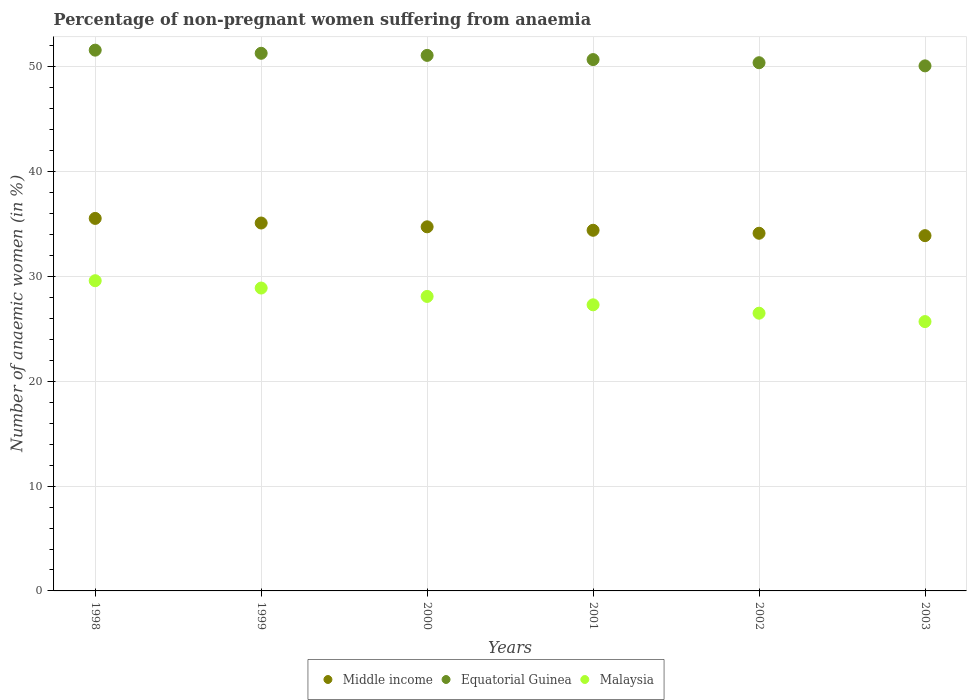How many different coloured dotlines are there?
Offer a terse response. 3. Is the number of dotlines equal to the number of legend labels?
Ensure brevity in your answer.  Yes. What is the percentage of non-pregnant women suffering from anaemia in Malaysia in 1999?
Your response must be concise. 28.9. Across all years, what is the maximum percentage of non-pregnant women suffering from anaemia in Malaysia?
Provide a succinct answer. 29.6. Across all years, what is the minimum percentage of non-pregnant women suffering from anaemia in Equatorial Guinea?
Keep it short and to the point. 50.1. In which year was the percentage of non-pregnant women suffering from anaemia in Malaysia maximum?
Your response must be concise. 1998. In which year was the percentage of non-pregnant women suffering from anaemia in Middle income minimum?
Make the answer very short. 2003. What is the total percentage of non-pregnant women suffering from anaemia in Equatorial Guinea in the graph?
Your answer should be very brief. 305.2. What is the difference between the percentage of non-pregnant women suffering from anaemia in Equatorial Guinea in 2000 and that in 2001?
Keep it short and to the point. 0.4. What is the difference between the percentage of non-pregnant women suffering from anaemia in Middle income in 2002 and the percentage of non-pregnant women suffering from anaemia in Malaysia in 2000?
Give a very brief answer. 6.03. What is the average percentage of non-pregnant women suffering from anaemia in Equatorial Guinea per year?
Keep it short and to the point. 50.87. In the year 2002, what is the difference between the percentage of non-pregnant women suffering from anaemia in Malaysia and percentage of non-pregnant women suffering from anaemia in Middle income?
Make the answer very short. -7.63. What is the ratio of the percentage of non-pregnant women suffering from anaemia in Middle income in 2000 to that in 2001?
Your answer should be compact. 1.01. What is the difference between the highest and the second highest percentage of non-pregnant women suffering from anaemia in Malaysia?
Give a very brief answer. 0.7. What is the difference between the highest and the lowest percentage of non-pregnant women suffering from anaemia in Middle income?
Give a very brief answer. 1.64. In how many years, is the percentage of non-pregnant women suffering from anaemia in Equatorial Guinea greater than the average percentage of non-pregnant women suffering from anaemia in Equatorial Guinea taken over all years?
Provide a succinct answer. 3. Is it the case that in every year, the sum of the percentage of non-pregnant women suffering from anaemia in Equatorial Guinea and percentage of non-pregnant women suffering from anaemia in Middle income  is greater than the percentage of non-pregnant women suffering from anaemia in Malaysia?
Provide a succinct answer. Yes. Does the percentage of non-pregnant women suffering from anaemia in Middle income monotonically increase over the years?
Provide a succinct answer. No. Is the percentage of non-pregnant women suffering from anaemia in Middle income strictly greater than the percentage of non-pregnant women suffering from anaemia in Malaysia over the years?
Your answer should be very brief. Yes. Is the percentage of non-pregnant women suffering from anaemia in Middle income strictly less than the percentage of non-pregnant women suffering from anaemia in Equatorial Guinea over the years?
Make the answer very short. Yes. How many years are there in the graph?
Offer a very short reply. 6. What is the difference between two consecutive major ticks on the Y-axis?
Provide a succinct answer. 10. Are the values on the major ticks of Y-axis written in scientific E-notation?
Make the answer very short. No. Does the graph contain grids?
Your answer should be compact. Yes. Where does the legend appear in the graph?
Provide a succinct answer. Bottom center. How are the legend labels stacked?
Offer a very short reply. Horizontal. What is the title of the graph?
Give a very brief answer. Percentage of non-pregnant women suffering from anaemia. Does "Latvia" appear as one of the legend labels in the graph?
Your response must be concise. No. What is the label or title of the Y-axis?
Make the answer very short. Number of anaemic women (in %). What is the Number of anaemic women (in %) of Middle income in 1998?
Your response must be concise. 35.54. What is the Number of anaemic women (in %) in Equatorial Guinea in 1998?
Make the answer very short. 51.6. What is the Number of anaemic women (in %) of Malaysia in 1998?
Ensure brevity in your answer.  29.6. What is the Number of anaemic women (in %) in Middle income in 1999?
Make the answer very short. 35.1. What is the Number of anaemic women (in %) of Equatorial Guinea in 1999?
Your response must be concise. 51.3. What is the Number of anaemic women (in %) of Malaysia in 1999?
Make the answer very short. 28.9. What is the Number of anaemic women (in %) of Middle income in 2000?
Offer a very short reply. 34.74. What is the Number of anaemic women (in %) of Equatorial Guinea in 2000?
Provide a succinct answer. 51.1. What is the Number of anaemic women (in %) in Malaysia in 2000?
Provide a succinct answer. 28.1. What is the Number of anaemic women (in %) in Middle income in 2001?
Provide a short and direct response. 34.41. What is the Number of anaemic women (in %) of Equatorial Guinea in 2001?
Your answer should be compact. 50.7. What is the Number of anaemic women (in %) in Malaysia in 2001?
Keep it short and to the point. 27.3. What is the Number of anaemic women (in %) in Middle income in 2002?
Your answer should be very brief. 34.13. What is the Number of anaemic women (in %) of Equatorial Guinea in 2002?
Your answer should be compact. 50.4. What is the Number of anaemic women (in %) of Malaysia in 2002?
Provide a short and direct response. 26.5. What is the Number of anaemic women (in %) in Middle income in 2003?
Make the answer very short. 33.9. What is the Number of anaemic women (in %) of Equatorial Guinea in 2003?
Your answer should be very brief. 50.1. What is the Number of anaemic women (in %) of Malaysia in 2003?
Ensure brevity in your answer.  25.7. Across all years, what is the maximum Number of anaemic women (in %) in Middle income?
Keep it short and to the point. 35.54. Across all years, what is the maximum Number of anaemic women (in %) in Equatorial Guinea?
Your answer should be compact. 51.6. Across all years, what is the maximum Number of anaemic women (in %) in Malaysia?
Offer a terse response. 29.6. Across all years, what is the minimum Number of anaemic women (in %) of Middle income?
Your answer should be very brief. 33.9. Across all years, what is the minimum Number of anaemic women (in %) of Equatorial Guinea?
Provide a succinct answer. 50.1. Across all years, what is the minimum Number of anaemic women (in %) of Malaysia?
Your response must be concise. 25.7. What is the total Number of anaemic women (in %) of Middle income in the graph?
Make the answer very short. 207.83. What is the total Number of anaemic women (in %) of Equatorial Guinea in the graph?
Your response must be concise. 305.2. What is the total Number of anaemic women (in %) in Malaysia in the graph?
Provide a short and direct response. 166.1. What is the difference between the Number of anaemic women (in %) of Middle income in 1998 and that in 1999?
Provide a succinct answer. 0.44. What is the difference between the Number of anaemic women (in %) in Malaysia in 1998 and that in 1999?
Offer a terse response. 0.7. What is the difference between the Number of anaemic women (in %) in Middle income in 1998 and that in 2000?
Ensure brevity in your answer.  0.8. What is the difference between the Number of anaemic women (in %) of Equatorial Guinea in 1998 and that in 2000?
Your answer should be compact. 0.5. What is the difference between the Number of anaemic women (in %) of Middle income in 1998 and that in 2001?
Provide a short and direct response. 1.13. What is the difference between the Number of anaemic women (in %) of Malaysia in 1998 and that in 2001?
Make the answer very short. 2.3. What is the difference between the Number of anaemic women (in %) in Middle income in 1998 and that in 2002?
Give a very brief answer. 1.42. What is the difference between the Number of anaemic women (in %) in Equatorial Guinea in 1998 and that in 2002?
Make the answer very short. 1.2. What is the difference between the Number of anaemic women (in %) in Middle income in 1998 and that in 2003?
Your response must be concise. 1.64. What is the difference between the Number of anaemic women (in %) in Middle income in 1999 and that in 2000?
Ensure brevity in your answer.  0.36. What is the difference between the Number of anaemic women (in %) of Equatorial Guinea in 1999 and that in 2000?
Your answer should be very brief. 0.2. What is the difference between the Number of anaemic women (in %) of Middle income in 1999 and that in 2001?
Ensure brevity in your answer.  0.69. What is the difference between the Number of anaemic women (in %) of Equatorial Guinea in 1999 and that in 2001?
Provide a short and direct response. 0.6. What is the difference between the Number of anaemic women (in %) of Malaysia in 1999 and that in 2001?
Your response must be concise. 1.6. What is the difference between the Number of anaemic women (in %) in Middle income in 1999 and that in 2002?
Your answer should be very brief. 0.98. What is the difference between the Number of anaemic women (in %) in Equatorial Guinea in 1999 and that in 2002?
Make the answer very short. 0.9. What is the difference between the Number of anaemic women (in %) in Middle income in 1999 and that in 2003?
Provide a short and direct response. 1.21. What is the difference between the Number of anaemic women (in %) in Malaysia in 1999 and that in 2003?
Provide a short and direct response. 3.2. What is the difference between the Number of anaemic women (in %) of Middle income in 2000 and that in 2001?
Provide a short and direct response. 0.33. What is the difference between the Number of anaemic women (in %) of Equatorial Guinea in 2000 and that in 2001?
Your answer should be very brief. 0.4. What is the difference between the Number of anaemic women (in %) of Middle income in 2000 and that in 2002?
Ensure brevity in your answer.  0.61. What is the difference between the Number of anaemic women (in %) of Equatorial Guinea in 2000 and that in 2002?
Offer a terse response. 0.7. What is the difference between the Number of anaemic women (in %) of Malaysia in 2000 and that in 2002?
Provide a short and direct response. 1.6. What is the difference between the Number of anaemic women (in %) of Middle income in 2000 and that in 2003?
Provide a short and direct response. 0.84. What is the difference between the Number of anaemic women (in %) in Equatorial Guinea in 2000 and that in 2003?
Your answer should be very brief. 1. What is the difference between the Number of anaemic women (in %) of Middle income in 2001 and that in 2002?
Make the answer very short. 0.28. What is the difference between the Number of anaemic women (in %) of Equatorial Guinea in 2001 and that in 2002?
Offer a very short reply. 0.3. What is the difference between the Number of anaemic women (in %) of Middle income in 2001 and that in 2003?
Your response must be concise. 0.51. What is the difference between the Number of anaemic women (in %) of Equatorial Guinea in 2001 and that in 2003?
Give a very brief answer. 0.6. What is the difference between the Number of anaemic women (in %) in Middle income in 2002 and that in 2003?
Provide a short and direct response. 0.23. What is the difference between the Number of anaemic women (in %) in Malaysia in 2002 and that in 2003?
Make the answer very short. 0.8. What is the difference between the Number of anaemic women (in %) of Middle income in 1998 and the Number of anaemic women (in %) of Equatorial Guinea in 1999?
Make the answer very short. -15.76. What is the difference between the Number of anaemic women (in %) in Middle income in 1998 and the Number of anaemic women (in %) in Malaysia in 1999?
Offer a terse response. 6.64. What is the difference between the Number of anaemic women (in %) in Equatorial Guinea in 1998 and the Number of anaemic women (in %) in Malaysia in 1999?
Provide a succinct answer. 22.7. What is the difference between the Number of anaemic women (in %) in Middle income in 1998 and the Number of anaemic women (in %) in Equatorial Guinea in 2000?
Provide a short and direct response. -15.56. What is the difference between the Number of anaemic women (in %) of Middle income in 1998 and the Number of anaemic women (in %) of Malaysia in 2000?
Offer a very short reply. 7.44. What is the difference between the Number of anaemic women (in %) of Equatorial Guinea in 1998 and the Number of anaemic women (in %) of Malaysia in 2000?
Provide a short and direct response. 23.5. What is the difference between the Number of anaemic women (in %) of Middle income in 1998 and the Number of anaemic women (in %) of Equatorial Guinea in 2001?
Your response must be concise. -15.16. What is the difference between the Number of anaemic women (in %) of Middle income in 1998 and the Number of anaemic women (in %) of Malaysia in 2001?
Your response must be concise. 8.24. What is the difference between the Number of anaemic women (in %) in Equatorial Guinea in 1998 and the Number of anaemic women (in %) in Malaysia in 2001?
Your response must be concise. 24.3. What is the difference between the Number of anaemic women (in %) in Middle income in 1998 and the Number of anaemic women (in %) in Equatorial Guinea in 2002?
Provide a short and direct response. -14.86. What is the difference between the Number of anaemic women (in %) of Middle income in 1998 and the Number of anaemic women (in %) of Malaysia in 2002?
Provide a short and direct response. 9.04. What is the difference between the Number of anaemic women (in %) of Equatorial Guinea in 1998 and the Number of anaemic women (in %) of Malaysia in 2002?
Provide a short and direct response. 25.1. What is the difference between the Number of anaemic women (in %) of Middle income in 1998 and the Number of anaemic women (in %) of Equatorial Guinea in 2003?
Offer a terse response. -14.56. What is the difference between the Number of anaemic women (in %) of Middle income in 1998 and the Number of anaemic women (in %) of Malaysia in 2003?
Your answer should be compact. 9.84. What is the difference between the Number of anaemic women (in %) of Equatorial Guinea in 1998 and the Number of anaemic women (in %) of Malaysia in 2003?
Your answer should be very brief. 25.9. What is the difference between the Number of anaemic women (in %) of Middle income in 1999 and the Number of anaemic women (in %) of Equatorial Guinea in 2000?
Ensure brevity in your answer.  -15.99. What is the difference between the Number of anaemic women (in %) in Middle income in 1999 and the Number of anaemic women (in %) in Malaysia in 2000?
Your answer should be very brief. 7. What is the difference between the Number of anaemic women (in %) in Equatorial Guinea in 1999 and the Number of anaemic women (in %) in Malaysia in 2000?
Provide a succinct answer. 23.2. What is the difference between the Number of anaemic women (in %) of Middle income in 1999 and the Number of anaemic women (in %) of Equatorial Guinea in 2001?
Offer a very short reply. -15.6. What is the difference between the Number of anaemic women (in %) in Middle income in 1999 and the Number of anaemic women (in %) in Malaysia in 2001?
Offer a terse response. 7.8. What is the difference between the Number of anaemic women (in %) in Middle income in 1999 and the Number of anaemic women (in %) in Equatorial Guinea in 2002?
Make the answer very short. -15.29. What is the difference between the Number of anaemic women (in %) in Middle income in 1999 and the Number of anaemic women (in %) in Malaysia in 2002?
Offer a very short reply. 8.61. What is the difference between the Number of anaemic women (in %) in Equatorial Guinea in 1999 and the Number of anaemic women (in %) in Malaysia in 2002?
Provide a succinct answer. 24.8. What is the difference between the Number of anaemic women (in %) of Middle income in 1999 and the Number of anaemic women (in %) of Equatorial Guinea in 2003?
Your answer should be compact. -14.99. What is the difference between the Number of anaemic women (in %) of Middle income in 1999 and the Number of anaemic women (in %) of Malaysia in 2003?
Offer a terse response. 9.4. What is the difference between the Number of anaemic women (in %) of Equatorial Guinea in 1999 and the Number of anaemic women (in %) of Malaysia in 2003?
Provide a short and direct response. 25.6. What is the difference between the Number of anaemic women (in %) of Middle income in 2000 and the Number of anaemic women (in %) of Equatorial Guinea in 2001?
Offer a terse response. -15.96. What is the difference between the Number of anaemic women (in %) in Middle income in 2000 and the Number of anaemic women (in %) in Malaysia in 2001?
Your answer should be compact. 7.44. What is the difference between the Number of anaemic women (in %) in Equatorial Guinea in 2000 and the Number of anaemic women (in %) in Malaysia in 2001?
Your response must be concise. 23.8. What is the difference between the Number of anaemic women (in %) in Middle income in 2000 and the Number of anaemic women (in %) in Equatorial Guinea in 2002?
Give a very brief answer. -15.66. What is the difference between the Number of anaemic women (in %) in Middle income in 2000 and the Number of anaemic women (in %) in Malaysia in 2002?
Keep it short and to the point. 8.24. What is the difference between the Number of anaemic women (in %) in Equatorial Guinea in 2000 and the Number of anaemic women (in %) in Malaysia in 2002?
Offer a terse response. 24.6. What is the difference between the Number of anaemic women (in %) in Middle income in 2000 and the Number of anaemic women (in %) in Equatorial Guinea in 2003?
Ensure brevity in your answer.  -15.36. What is the difference between the Number of anaemic women (in %) in Middle income in 2000 and the Number of anaemic women (in %) in Malaysia in 2003?
Your answer should be compact. 9.04. What is the difference between the Number of anaemic women (in %) of Equatorial Guinea in 2000 and the Number of anaemic women (in %) of Malaysia in 2003?
Offer a terse response. 25.4. What is the difference between the Number of anaemic women (in %) in Middle income in 2001 and the Number of anaemic women (in %) in Equatorial Guinea in 2002?
Provide a succinct answer. -15.99. What is the difference between the Number of anaemic women (in %) of Middle income in 2001 and the Number of anaemic women (in %) of Malaysia in 2002?
Provide a short and direct response. 7.91. What is the difference between the Number of anaemic women (in %) of Equatorial Guinea in 2001 and the Number of anaemic women (in %) of Malaysia in 2002?
Your answer should be compact. 24.2. What is the difference between the Number of anaemic women (in %) in Middle income in 2001 and the Number of anaemic women (in %) in Equatorial Guinea in 2003?
Your answer should be very brief. -15.69. What is the difference between the Number of anaemic women (in %) of Middle income in 2001 and the Number of anaemic women (in %) of Malaysia in 2003?
Offer a very short reply. 8.71. What is the difference between the Number of anaemic women (in %) in Equatorial Guinea in 2001 and the Number of anaemic women (in %) in Malaysia in 2003?
Offer a very short reply. 25. What is the difference between the Number of anaemic women (in %) in Middle income in 2002 and the Number of anaemic women (in %) in Equatorial Guinea in 2003?
Provide a succinct answer. -15.97. What is the difference between the Number of anaemic women (in %) in Middle income in 2002 and the Number of anaemic women (in %) in Malaysia in 2003?
Your answer should be compact. 8.43. What is the difference between the Number of anaemic women (in %) of Equatorial Guinea in 2002 and the Number of anaemic women (in %) of Malaysia in 2003?
Make the answer very short. 24.7. What is the average Number of anaemic women (in %) in Middle income per year?
Provide a succinct answer. 34.64. What is the average Number of anaemic women (in %) of Equatorial Guinea per year?
Give a very brief answer. 50.87. What is the average Number of anaemic women (in %) of Malaysia per year?
Provide a short and direct response. 27.68. In the year 1998, what is the difference between the Number of anaemic women (in %) of Middle income and Number of anaemic women (in %) of Equatorial Guinea?
Your answer should be very brief. -16.06. In the year 1998, what is the difference between the Number of anaemic women (in %) in Middle income and Number of anaemic women (in %) in Malaysia?
Give a very brief answer. 5.94. In the year 1998, what is the difference between the Number of anaemic women (in %) of Equatorial Guinea and Number of anaemic women (in %) of Malaysia?
Ensure brevity in your answer.  22. In the year 1999, what is the difference between the Number of anaemic women (in %) in Middle income and Number of anaemic women (in %) in Equatorial Guinea?
Your answer should be compact. -16.2. In the year 1999, what is the difference between the Number of anaemic women (in %) of Middle income and Number of anaemic women (in %) of Malaysia?
Keep it short and to the point. 6.21. In the year 1999, what is the difference between the Number of anaemic women (in %) of Equatorial Guinea and Number of anaemic women (in %) of Malaysia?
Offer a very short reply. 22.4. In the year 2000, what is the difference between the Number of anaemic women (in %) of Middle income and Number of anaemic women (in %) of Equatorial Guinea?
Your answer should be very brief. -16.36. In the year 2000, what is the difference between the Number of anaemic women (in %) in Middle income and Number of anaemic women (in %) in Malaysia?
Your answer should be very brief. 6.64. In the year 2001, what is the difference between the Number of anaemic women (in %) of Middle income and Number of anaemic women (in %) of Equatorial Guinea?
Your answer should be compact. -16.29. In the year 2001, what is the difference between the Number of anaemic women (in %) of Middle income and Number of anaemic women (in %) of Malaysia?
Keep it short and to the point. 7.11. In the year 2001, what is the difference between the Number of anaemic women (in %) in Equatorial Guinea and Number of anaemic women (in %) in Malaysia?
Provide a succinct answer. 23.4. In the year 2002, what is the difference between the Number of anaemic women (in %) of Middle income and Number of anaemic women (in %) of Equatorial Guinea?
Offer a very short reply. -16.27. In the year 2002, what is the difference between the Number of anaemic women (in %) of Middle income and Number of anaemic women (in %) of Malaysia?
Keep it short and to the point. 7.63. In the year 2002, what is the difference between the Number of anaemic women (in %) of Equatorial Guinea and Number of anaemic women (in %) of Malaysia?
Ensure brevity in your answer.  23.9. In the year 2003, what is the difference between the Number of anaemic women (in %) of Middle income and Number of anaemic women (in %) of Equatorial Guinea?
Offer a terse response. -16.2. In the year 2003, what is the difference between the Number of anaemic women (in %) of Middle income and Number of anaemic women (in %) of Malaysia?
Your answer should be compact. 8.2. In the year 2003, what is the difference between the Number of anaemic women (in %) in Equatorial Guinea and Number of anaemic women (in %) in Malaysia?
Provide a short and direct response. 24.4. What is the ratio of the Number of anaemic women (in %) in Middle income in 1998 to that in 1999?
Provide a short and direct response. 1.01. What is the ratio of the Number of anaemic women (in %) in Equatorial Guinea in 1998 to that in 1999?
Provide a short and direct response. 1.01. What is the ratio of the Number of anaemic women (in %) in Malaysia in 1998 to that in 1999?
Your response must be concise. 1.02. What is the ratio of the Number of anaemic women (in %) of Middle income in 1998 to that in 2000?
Offer a terse response. 1.02. What is the ratio of the Number of anaemic women (in %) of Equatorial Guinea in 1998 to that in 2000?
Your response must be concise. 1.01. What is the ratio of the Number of anaemic women (in %) of Malaysia in 1998 to that in 2000?
Make the answer very short. 1.05. What is the ratio of the Number of anaemic women (in %) of Middle income in 1998 to that in 2001?
Ensure brevity in your answer.  1.03. What is the ratio of the Number of anaemic women (in %) in Equatorial Guinea in 1998 to that in 2001?
Your answer should be compact. 1.02. What is the ratio of the Number of anaemic women (in %) in Malaysia in 1998 to that in 2001?
Your answer should be very brief. 1.08. What is the ratio of the Number of anaemic women (in %) in Middle income in 1998 to that in 2002?
Provide a short and direct response. 1.04. What is the ratio of the Number of anaemic women (in %) of Equatorial Guinea in 1998 to that in 2002?
Your response must be concise. 1.02. What is the ratio of the Number of anaemic women (in %) of Malaysia in 1998 to that in 2002?
Make the answer very short. 1.12. What is the ratio of the Number of anaemic women (in %) of Middle income in 1998 to that in 2003?
Keep it short and to the point. 1.05. What is the ratio of the Number of anaemic women (in %) in Equatorial Guinea in 1998 to that in 2003?
Make the answer very short. 1.03. What is the ratio of the Number of anaemic women (in %) in Malaysia in 1998 to that in 2003?
Provide a succinct answer. 1.15. What is the ratio of the Number of anaemic women (in %) in Middle income in 1999 to that in 2000?
Ensure brevity in your answer.  1.01. What is the ratio of the Number of anaemic women (in %) in Equatorial Guinea in 1999 to that in 2000?
Give a very brief answer. 1. What is the ratio of the Number of anaemic women (in %) in Malaysia in 1999 to that in 2000?
Offer a terse response. 1.03. What is the ratio of the Number of anaemic women (in %) of Middle income in 1999 to that in 2001?
Make the answer very short. 1.02. What is the ratio of the Number of anaemic women (in %) in Equatorial Guinea in 1999 to that in 2001?
Your answer should be compact. 1.01. What is the ratio of the Number of anaemic women (in %) of Malaysia in 1999 to that in 2001?
Your answer should be very brief. 1.06. What is the ratio of the Number of anaemic women (in %) in Middle income in 1999 to that in 2002?
Ensure brevity in your answer.  1.03. What is the ratio of the Number of anaemic women (in %) in Equatorial Guinea in 1999 to that in 2002?
Provide a short and direct response. 1.02. What is the ratio of the Number of anaemic women (in %) in Malaysia in 1999 to that in 2002?
Provide a succinct answer. 1.09. What is the ratio of the Number of anaemic women (in %) in Middle income in 1999 to that in 2003?
Offer a very short reply. 1.04. What is the ratio of the Number of anaemic women (in %) in Malaysia in 1999 to that in 2003?
Provide a short and direct response. 1.12. What is the ratio of the Number of anaemic women (in %) of Middle income in 2000 to that in 2001?
Your response must be concise. 1.01. What is the ratio of the Number of anaemic women (in %) of Equatorial Guinea in 2000 to that in 2001?
Give a very brief answer. 1.01. What is the ratio of the Number of anaemic women (in %) in Malaysia in 2000 to that in 2001?
Make the answer very short. 1.03. What is the ratio of the Number of anaemic women (in %) of Equatorial Guinea in 2000 to that in 2002?
Your answer should be very brief. 1.01. What is the ratio of the Number of anaemic women (in %) in Malaysia in 2000 to that in 2002?
Give a very brief answer. 1.06. What is the ratio of the Number of anaemic women (in %) of Middle income in 2000 to that in 2003?
Your answer should be compact. 1.02. What is the ratio of the Number of anaemic women (in %) in Equatorial Guinea in 2000 to that in 2003?
Your answer should be compact. 1.02. What is the ratio of the Number of anaemic women (in %) of Malaysia in 2000 to that in 2003?
Provide a short and direct response. 1.09. What is the ratio of the Number of anaemic women (in %) of Middle income in 2001 to that in 2002?
Your answer should be compact. 1.01. What is the ratio of the Number of anaemic women (in %) of Equatorial Guinea in 2001 to that in 2002?
Offer a very short reply. 1.01. What is the ratio of the Number of anaemic women (in %) of Malaysia in 2001 to that in 2002?
Give a very brief answer. 1.03. What is the ratio of the Number of anaemic women (in %) of Middle income in 2001 to that in 2003?
Offer a very short reply. 1.02. What is the ratio of the Number of anaemic women (in %) in Malaysia in 2001 to that in 2003?
Your response must be concise. 1.06. What is the ratio of the Number of anaemic women (in %) in Malaysia in 2002 to that in 2003?
Your response must be concise. 1.03. What is the difference between the highest and the second highest Number of anaemic women (in %) of Middle income?
Offer a very short reply. 0.44. What is the difference between the highest and the second highest Number of anaemic women (in %) in Equatorial Guinea?
Offer a terse response. 0.3. What is the difference between the highest and the lowest Number of anaemic women (in %) in Middle income?
Your answer should be very brief. 1.64. 